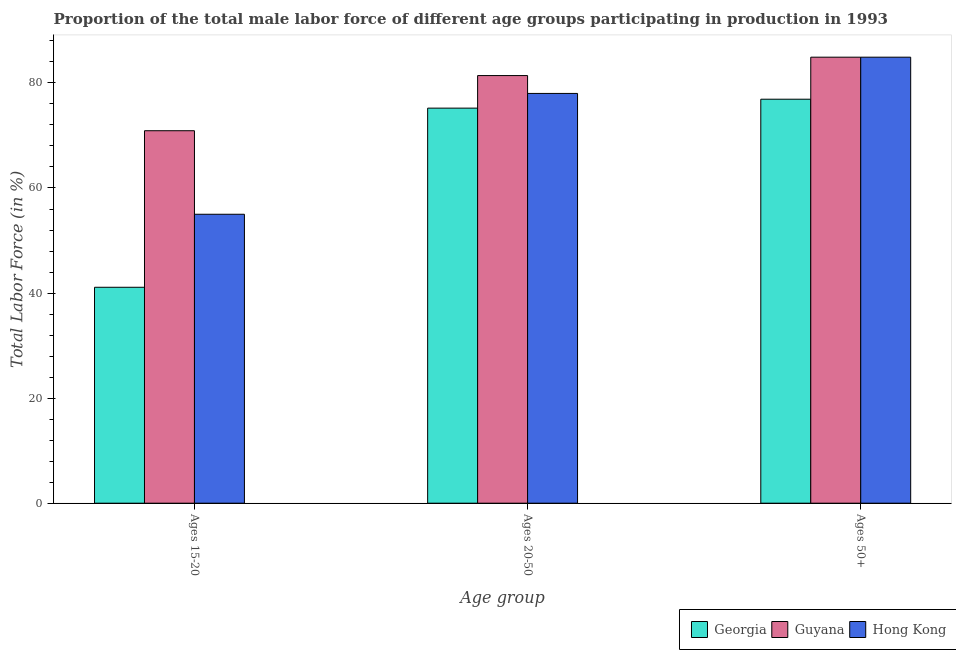How many groups of bars are there?
Provide a short and direct response. 3. How many bars are there on the 1st tick from the right?
Offer a terse response. 3. What is the label of the 3rd group of bars from the left?
Offer a terse response. Ages 50+. What is the percentage of male labor force above age 50 in Guyana?
Make the answer very short. 84.9. Across all countries, what is the maximum percentage of male labor force above age 50?
Give a very brief answer. 84.9. Across all countries, what is the minimum percentage of male labor force above age 50?
Provide a succinct answer. 76.9. In which country was the percentage of male labor force within the age group 15-20 maximum?
Keep it short and to the point. Guyana. In which country was the percentage of male labor force within the age group 20-50 minimum?
Your answer should be compact. Georgia. What is the total percentage of male labor force above age 50 in the graph?
Keep it short and to the point. 246.7. What is the difference between the percentage of male labor force within the age group 20-50 in Georgia and that in Guyana?
Make the answer very short. -6.2. What is the difference between the percentage of male labor force within the age group 20-50 in Georgia and the percentage of male labor force above age 50 in Hong Kong?
Ensure brevity in your answer.  -9.7. What is the average percentage of male labor force within the age group 15-20 per country?
Your answer should be very brief. 55.67. What is the difference between the percentage of male labor force within the age group 15-20 and percentage of male labor force within the age group 20-50 in Georgia?
Give a very brief answer. -34.1. What is the ratio of the percentage of male labor force above age 50 in Guyana to that in Georgia?
Offer a terse response. 1.1. What is the difference between the highest and the second highest percentage of male labor force above age 50?
Provide a short and direct response. 0. What is the difference between the highest and the lowest percentage of male labor force within the age group 15-20?
Offer a terse response. 29.8. Is the sum of the percentage of male labor force within the age group 20-50 in Hong Kong and Georgia greater than the maximum percentage of male labor force above age 50 across all countries?
Ensure brevity in your answer.  Yes. What does the 1st bar from the left in Ages 20-50 represents?
Your response must be concise. Georgia. What does the 1st bar from the right in Ages 20-50 represents?
Keep it short and to the point. Hong Kong. Is it the case that in every country, the sum of the percentage of male labor force within the age group 15-20 and percentage of male labor force within the age group 20-50 is greater than the percentage of male labor force above age 50?
Give a very brief answer. Yes. Are all the bars in the graph horizontal?
Offer a terse response. No. How many countries are there in the graph?
Make the answer very short. 3. Are the values on the major ticks of Y-axis written in scientific E-notation?
Keep it short and to the point. No. Does the graph contain grids?
Give a very brief answer. No. Where does the legend appear in the graph?
Your response must be concise. Bottom right. How many legend labels are there?
Provide a short and direct response. 3. How are the legend labels stacked?
Offer a very short reply. Horizontal. What is the title of the graph?
Your answer should be very brief. Proportion of the total male labor force of different age groups participating in production in 1993. Does "Mexico" appear as one of the legend labels in the graph?
Your answer should be compact. No. What is the label or title of the X-axis?
Your answer should be compact. Age group. What is the label or title of the Y-axis?
Offer a very short reply. Total Labor Force (in %). What is the Total Labor Force (in %) of Georgia in Ages 15-20?
Your response must be concise. 41.1. What is the Total Labor Force (in %) of Guyana in Ages 15-20?
Provide a short and direct response. 70.9. What is the Total Labor Force (in %) of Georgia in Ages 20-50?
Provide a short and direct response. 75.2. What is the Total Labor Force (in %) of Guyana in Ages 20-50?
Your response must be concise. 81.4. What is the Total Labor Force (in %) of Georgia in Ages 50+?
Provide a succinct answer. 76.9. What is the Total Labor Force (in %) in Guyana in Ages 50+?
Your answer should be compact. 84.9. What is the Total Labor Force (in %) in Hong Kong in Ages 50+?
Offer a terse response. 84.9. Across all Age group, what is the maximum Total Labor Force (in %) in Georgia?
Give a very brief answer. 76.9. Across all Age group, what is the maximum Total Labor Force (in %) of Guyana?
Your response must be concise. 84.9. Across all Age group, what is the maximum Total Labor Force (in %) of Hong Kong?
Ensure brevity in your answer.  84.9. Across all Age group, what is the minimum Total Labor Force (in %) in Georgia?
Ensure brevity in your answer.  41.1. Across all Age group, what is the minimum Total Labor Force (in %) of Guyana?
Make the answer very short. 70.9. What is the total Total Labor Force (in %) of Georgia in the graph?
Offer a terse response. 193.2. What is the total Total Labor Force (in %) of Guyana in the graph?
Provide a short and direct response. 237.2. What is the total Total Labor Force (in %) in Hong Kong in the graph?
Provide a succinct answer. 217.9. What is the difference between the Total Labor Force (in %) in Georgia in Ages 15-20 and that in Ages 20-50?
Make the answer very short. -34.1. What is the difference between the Total Labor Force (in %) of Guyana in Ages 15-20 and that in Ages 20-50?
Make the answer very short. -10.5. What is the difference between the Total Labor Force (in %) of Georgia in Ages 15-20 and that in Ages 50+?
Your answer should be very brief. -35.8. What is the difference between the Total Labor Force (in %) of Hong Kong in Ages 15-20 and that in Ages 50+?
Your answer should be very brief. -29.9. What is the difference between the Total Labor Force (in %) of Georgia in Ages 20-50 and that in Ages 50+?
Provide a short and direct response. -1.7. What is the difference between the Total Labor Force (in %) of Georgia in Ages 15-20 and the Total Labor Force (in %) of Guyana in Ages 20-50?
Ensure brevity in your answer.  -40.3. What is the difference between the Total Labor Force (in %) of Georgia in Ages 15-20 and the Total Labor Force (in %) of Hong Kong in Ages 20-50?
Provide a succinct answer. -36.9. What is the difference between the Total Labor Force (in %) of Guyana in Ages 15-20 and the Total Labor Force (in %) of Hong Kong in Ages 20-50?
Give a very brief answer. -7.1. What is the difference between the Total Labor Force (in %) of Georgia in Ages 15-20 and the Total Labor Force (in %) of Guyana in Ages 50+?
Your answer should be very brief. -43.8. What is the difference between the Total Labor Force (in %) in Georgia in Ages 15-20 and the Total Labor Force (in %) in Hong Kong in Ages 50+?
Offer a very short reply. -43.8. What is the difference between the Total Labor Force (in %) of Georgia in Ages 20-50 and the Total Labor Force (in %) of Hong Kong in Ages 50+?
Your answer should be very brief. -9.7. What is the difference between the Total Labor Force (in %) of Guyana in Ages 20-50 and the Total Labor Force (in %) of Hong Kong in Ages 50+?
Offer a terse response. -3.5. What is the average Total Labor Force (in %) of Georgia per Age group?
Your answer should be compact. 64.4. What is the average Total Labor Force (in %) of Guyana per Age group?
Your answer should be very brief. 79.07. What is the average Total Labor Force (in %) in Hong Kong per Age group?
Your answer should be compact. 72.63. What is the difference between the Total Labor Force (in %) in Georgia and Total Labor Force (in %) in Guyana in Ages 15-20?
Your answer should be very brief. -29.8. What is the difference between the Total Labor Force (in %) in Georgia and Total Labor Force (in %) in Hong Kong in Ages 15-20?
Give a very brief answer. -13.9. What is the difference between the Total Labor Force (in %) of Georgia and Total Labor Force (in %) of Guyana in Ages 20-50?
Your answer should be very brief. -6.2. What is the difference between the Total Labor Force (in %) of Georgia and Total Labor Force (in %) of Hong Kong in Ages 20-50?
Provide a succinct answer. -2.8. What is the difference between the Total Labor Force (in %) in Georgia and Total Labor Force (in %) in Hong Kong in Ages 50+?
Offer a terse response. -8. What is the difference between the Total Labor Force (in %) of Guyana and Total Labor Force (in %) of Hong Kong in Ages 50+?
Give a very brief answer. 0. What is the ratio of the Total Labor Force (in %) in Georgia in Ages 15-20 to that in Ages 20-50?
Keep it short and to the point. 0.55. What is the ratio of the Total Labor Force (in %) of Guyana in Ages 15-20 to that in Ages 20-50?
Make the answer very short. 0.87. What is the ratio of the Total Labor Force (in %) in Hong Kong in Ages 15-20 to that in Ages 20-50?
Your answer should be very brief. 0.71. What is the ratio of the Total Labor Force (in %) in Georgia in Ages 15-20 to that in Ages 50+?
Provide a short and direct response. 0.53. What is the ratio of the Total Labor Force (in %) of Guyana in Ages 15-20 to that in Ages 50+?
Give a very brief answer. 0.84. What is the ratio of the Total Labor Force (in %) in Hong Kong in Ages 15-20 to that in Ages 50+?
Your response must be concise. 0.65. What is the ratio of the Total Labor Force (in %) in Georgia in Ages 20-50 to that in Ages 50+?
Your answer should be compact. 0.98. What is the ratio of the Total Labor Force (in %) of Guyana in Ages 20-50 to that in Ages 50+?
Your answer should be very brief. 0.96. What is the ratio of the Total Labor Force (in %) of Hong Kong in Ages 20-50 to that in Ages 50+?
Your answer should be very brief. 0.92. What is the difference between the highest and the lowest Total Labor Force (in %) of Georgia?
Offer a very short reply. 35.8. What is the difference between the highest and the lowest Total Labor Force (in %) of Hong Kong?
Make the answer very short. 29.9. 